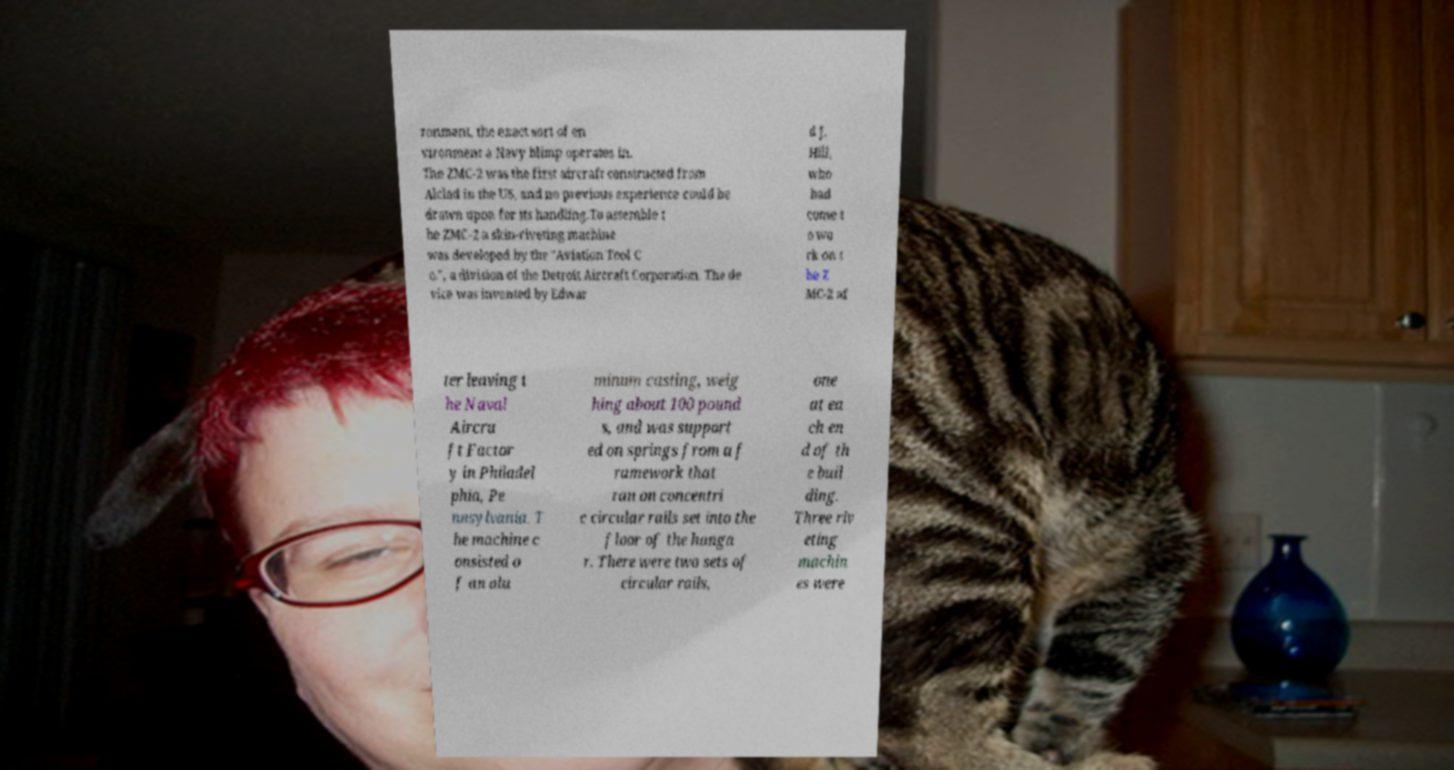Please read and relay the text visible in this image. What does it say? ronment, the exact sort of en vironment a Navy blimp operates in. The ZMC-2 was the first aircraft constructed from Alclad in the US, and no previous experience could be drawn upon for its handling.To assemble t he ZMC-2 a skin-riveting machine was developed by the "Aviation Tool C o.", a division of the Detroit Aircraft Corporation. The de vice was invented by Edwar d J. Hill, who had come t o wo rk on t he Z MC-2 af ter leaving t he Naval Aircra ft Factor y in Philadel phia, Pe nnsylvania. T he machine c onsisted o f an alu minum casting, weig hing about 100 pound s, and was support ed on springs from a f ramework that ran on concentri c circular rails set into the floor of the hanga r. There were two sets of circular rails, one at ea ch en d of th e buil ding. Three riv eting machin es were 